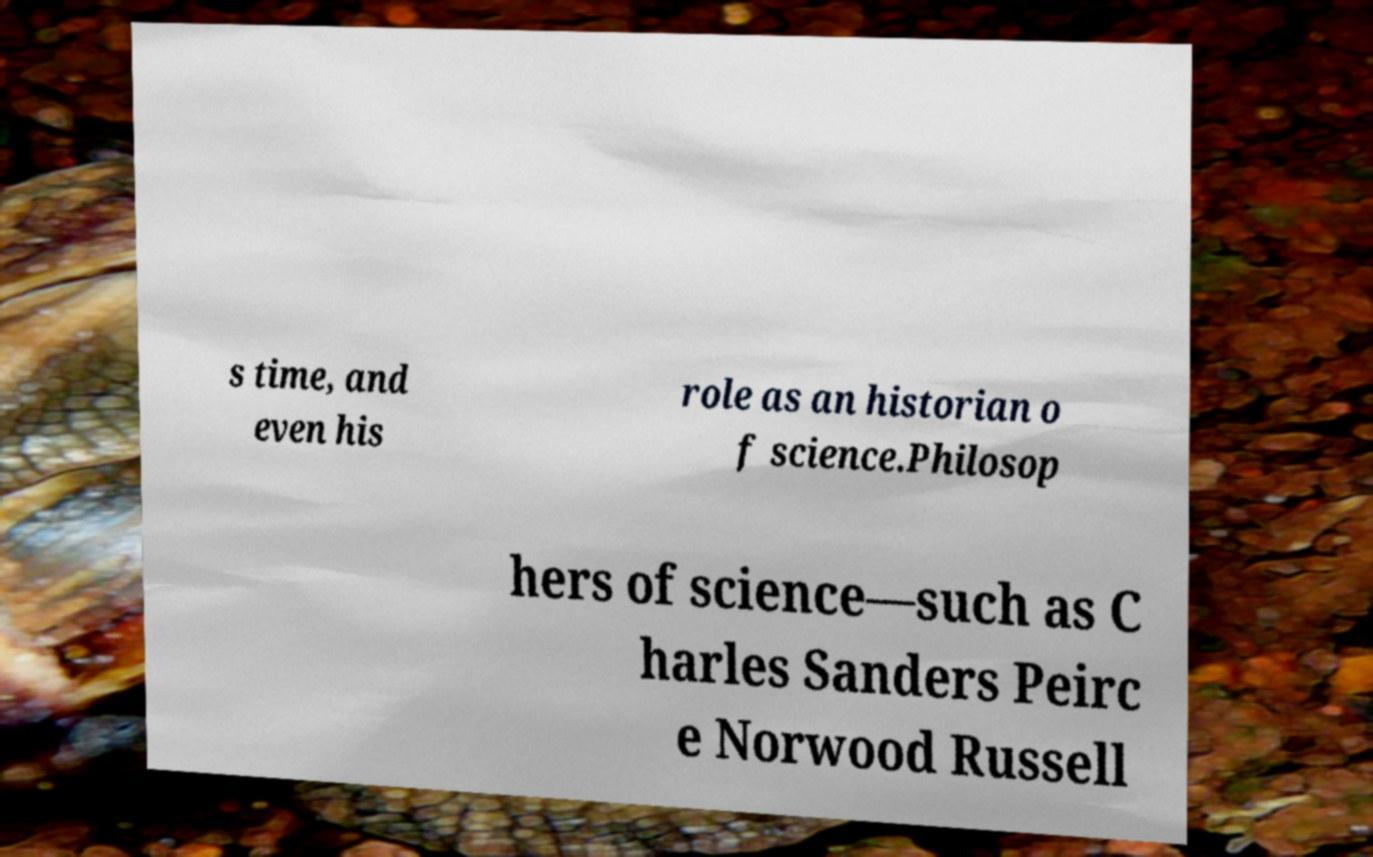I need the written content from this picture converted into text. Can you do that? s time, and even his role as an historian o f science.Philosop hers of science—such as C harles Sanders Peirc e Norwood Russell 